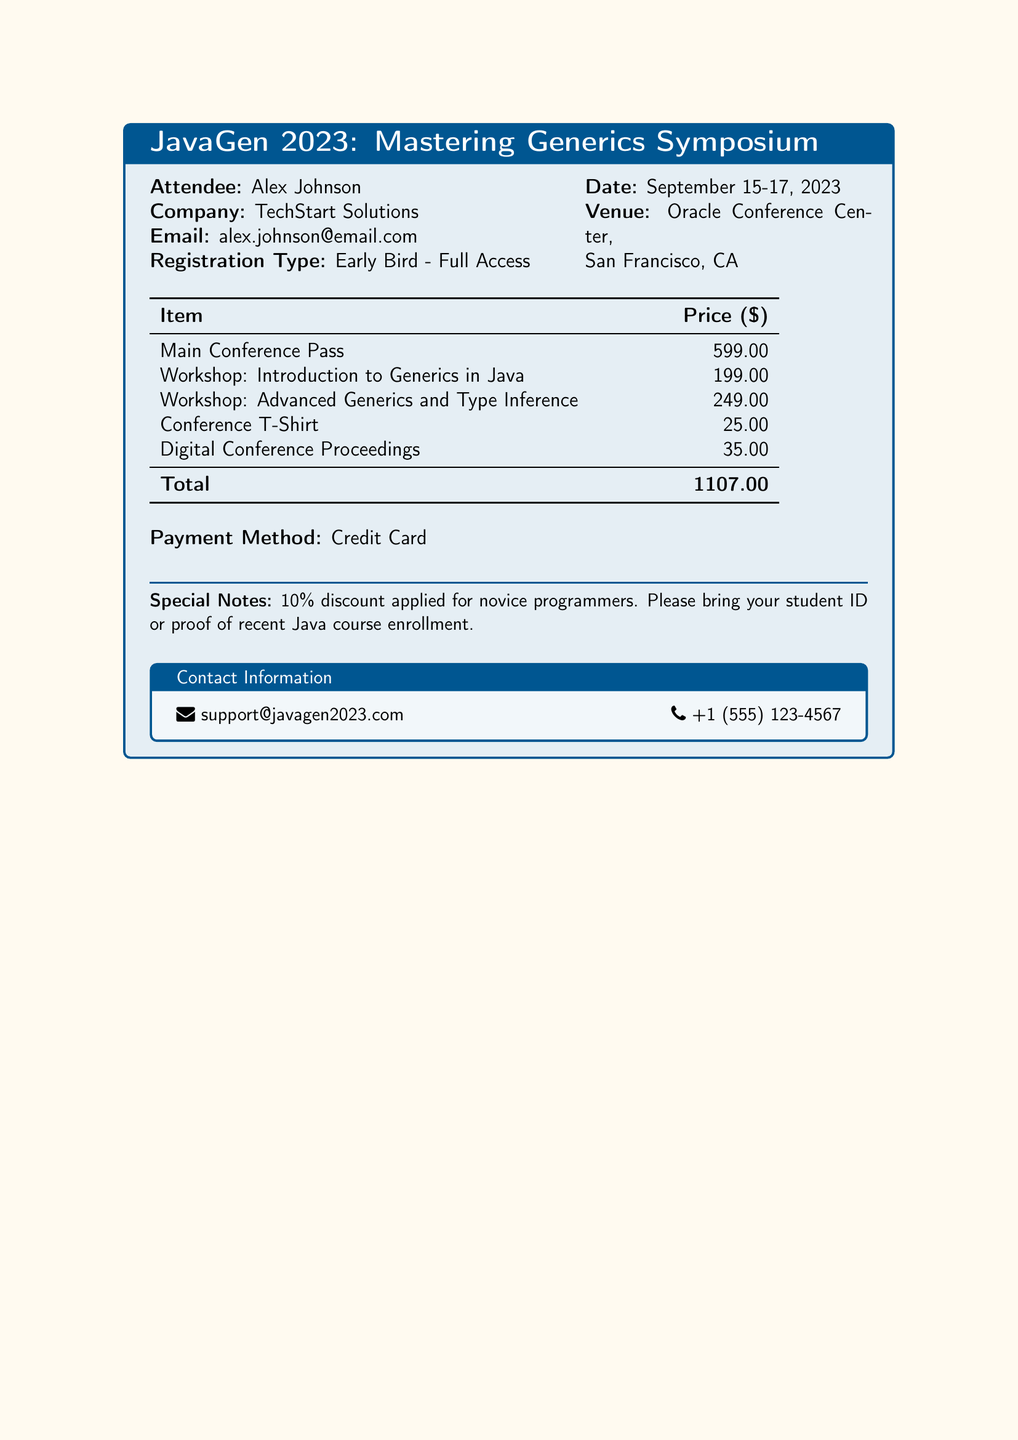What is the name of the symposium? The name of the symposium is presented in the title box at the top of the document.
Answer: JavaGen 2023: Mastering Generics Symposium Who is the attendee? The attendee's name is listed in the section detailing personal information of the registration.
Answer: Alex Johnson What is the total registration fee? The total registration fee is the sum of all the listed costs for the items.
Answer: 1107.00 When is the event taking place? The date of the event is stated in the document under the date section.
Answer: September 15-17, 2023 What type of registration did the attendee select? The type of registration is specified in the attendee's information section.
Answer: Early Bird - Full Access How much does the Advanced Generics workshop cost? The cost for the Advanced Generics workshop can be found in the itemized list of costs in the document.
Answer: 249.00 What is the venue for the symposium? The venue is mentioned in the information section regarding the event location.
Answer: Oracle Conference Center, San Francisco, CA What discount is applied for novice programmers? The discount for novice programmers is explicitly noted in the special notes section of the document.
Answer: 10% What item costs 25.00? The prices for each item are detailed in the itemized list, which includes the Conference T-Shirt.
Answer: Conference T-Shirt 